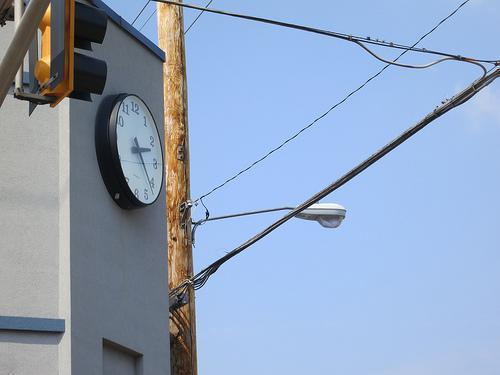How many street lights in the photo?
Give a very brief answer. 1. 